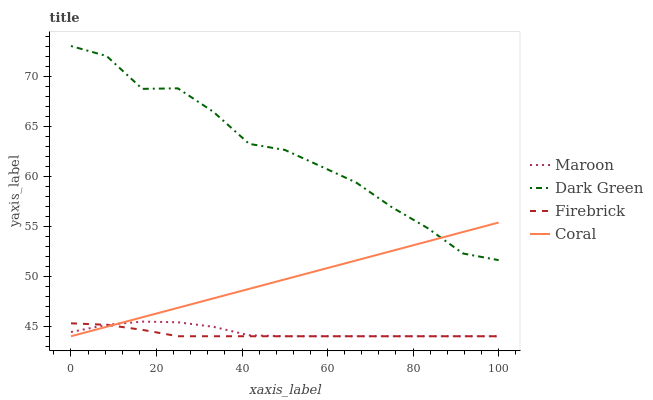Does Firebrick have the minimum area under the curve?
Answer yes or no. Yes. Does Dark Green have the maximum area under the curve?
Answer yes or no. Yes. Does Coral have the minimum area under the curve?
Answer yes or no. No. Does Coral have the maximum area under the curve?
Answer yes or no. No. Is Coral the smoothest?
Answer yes or no. Yes. Is Dark Green the roughest?
Answer yes or no. Yes. Is Maroon the smoothest?
Answer yes or no. No. Is Maroon the roughest?
Answer yes or no. No. Does Firebrick have the lowest value?
Answer yes or no. Yes. Does Dark Green have the lowest value?
Answer yes or no. No. Does Dark Green have the highest value?
Answer yes or no. Yes. Does Coral have the highest value?
Answer yes or no. No. Is Firebrick less than Dark Green?
Answer yes or no. Yes. Is Dark Green greater than Maroon?
Answer yes or no. Yes. Does Firebrick intersect Coral?
Answer yes or no. Yes. Is Firebrick less than Coral?
Answer yes or no. No. Is Firebrick greater than Coral?
Answer yes or no. No. Does Firebrick intersect Dark Green?
Answer yes or no. No. 